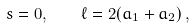Convert formula to latex. <formula><loc_0><loc_0><loc_500><loc_500>s = 0 , \quad \ell = 2 ( a _ { 1 } + a _ { 2 } ) \, ,</formula> 